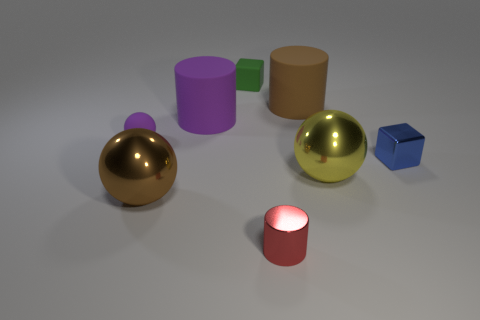What number of objects are large cyan rubber cubes or small blue blocks?
Offer a terse response. 1. Are any tiny shiny things visible?
Give a very brief answer. Yes. Do the large brown object on the right side of the tiny red metal object and the big brown ball have the same material?
Your answer should be compact. No. Is there a brown shiny object that has the same shape as the big brown matte object?
Keep it short and to the point. No. Are there the same number of blocks that are behind the blue metallic block and large brown matte cylinders?
Offer a terse response. Yes. What material is the large sphere that is in front of the large sphere right of the brown rubber object?
Your answer should be very brief. Metal. What shape is the small green thing?
Give a very brief answer. Cube. Are there an equal number of tiny green matte blocks behind the big brown cylinder and large brown objects in front of the small purple matte thing?
Provide a succinct answer. Yes. Do the cube that is in front of the small matte sphere and the big metallic sphere right of the brown metal object have the same color?
Offer a very short reply. No. Is the number of small rubber spheres that are right of the large yellow thing greater than the number of small yellow rubber things?
Ensure brevity in your answer.  No. 